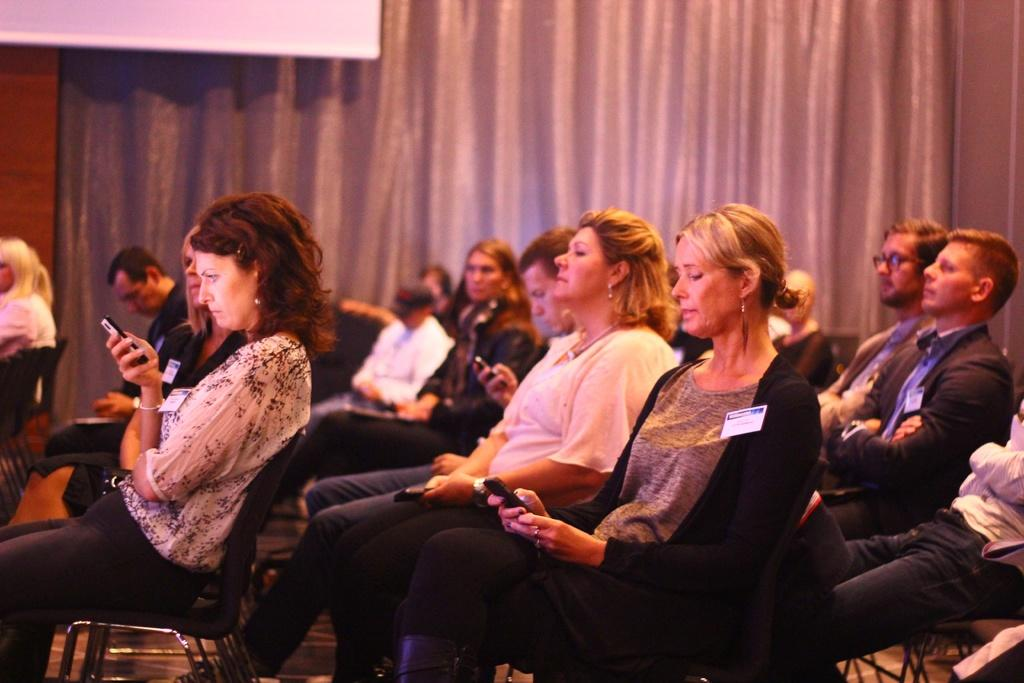What are the people in the image doing? The people in the image are sitting on chairs. What objects are some people holding in the image? Some people are holding mobile phones in the image. What type of window treatment can be seen in the image? There is a curtain visible in the image. What type of wine is being served by the writer in the image? There is no writer or wine present in the image. 